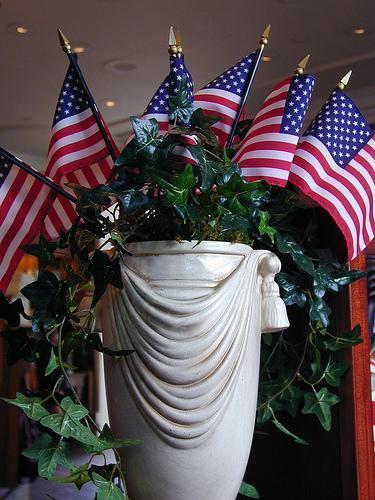How many flags are there?
Give a very brief answer. 6. 